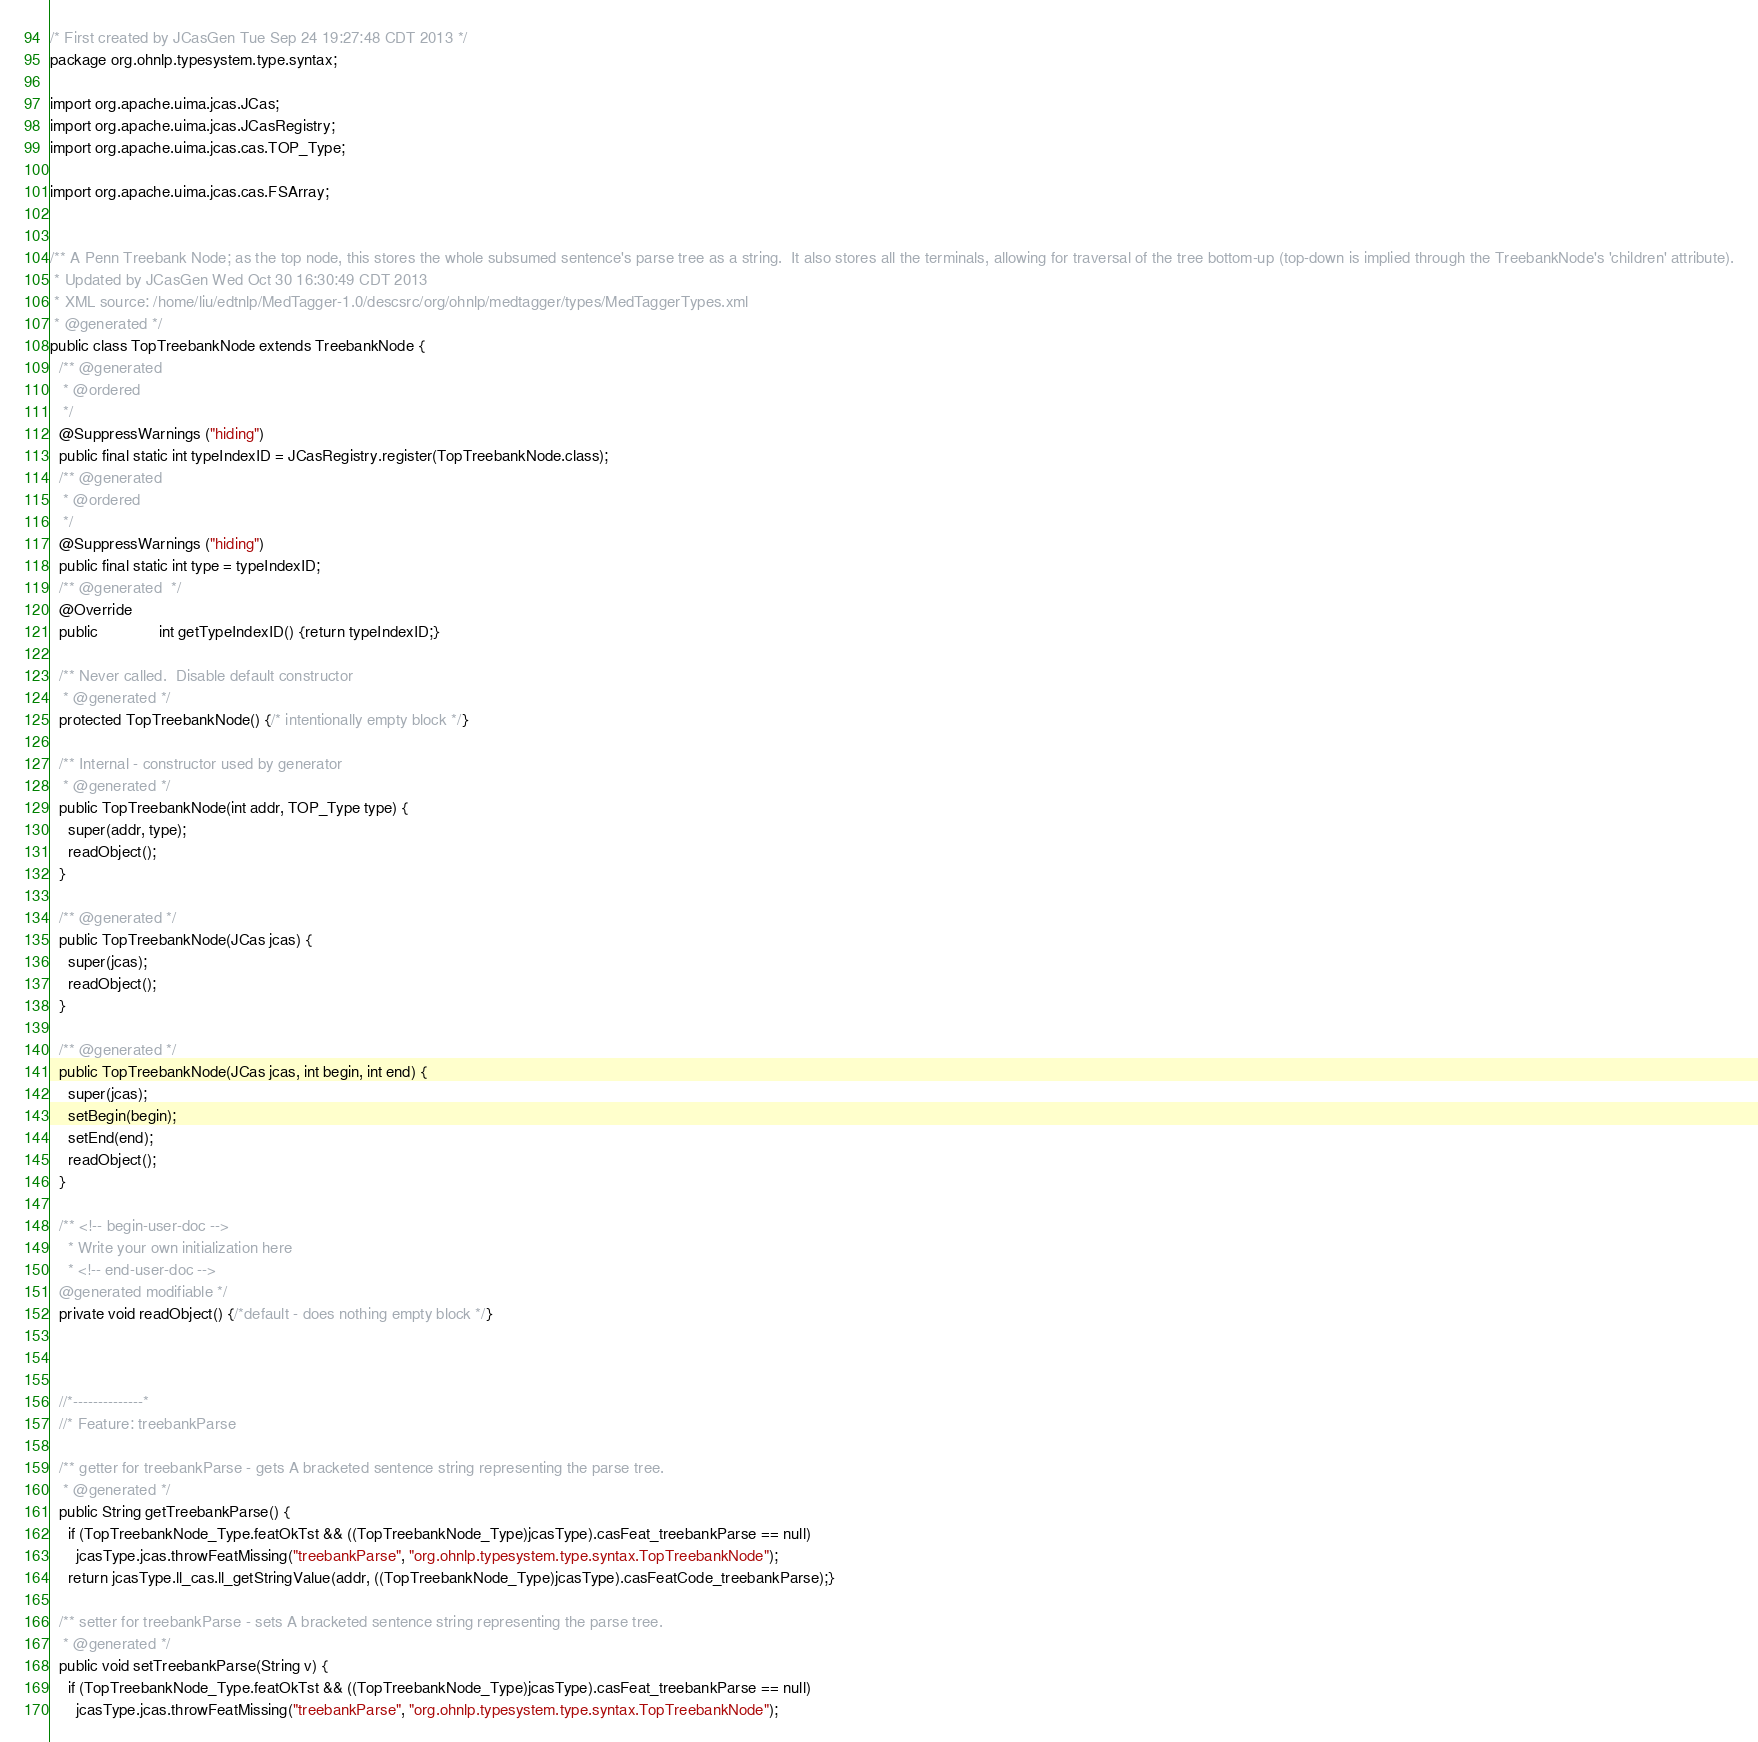Convert code to text. <code><loc_0><loc_0><loc_500><loc_500><_Java_>

/* First created by JCasGen Tue Sep 24 19:27:48 CDT 2013 */
package org.ohnlp.typesystem.type.syntax;

import org.apache.uima.jcas.JCas; 
import org.apache.uima.jcas.JCasRegistry;
import org.apache.uima.jcas.cas.TOP_Type;

import org.apache.uima.jcas.cas.FSArray;


/** A Penn Treebank Node; as the top node, this stores the whole subsumed sentence's parse tree as a string.  It also stores all the terminals, allowing for traversal of the tree bottom-up (top-down is implied through the TreebankNode's 'children' attribute).
 * Updated by JCasGen Wed Oct 30 16:30:49 CDT 2013
 * XML source: /home/liu/edtnlp/MedTagger-1.0/descsrc/org/ohnlp/medtagger/types/MedTaggerTypes.xml
 * @generated */
public class TopTreebankNode extends TreebankNode {
  /** @generated
   * @ordered 
   */
  @SuppressWarnings ("hiding")
  public final static int typeIndexID = JCasRegistry.register(TopTreebankNode.class);
  /** @generated
   * @ordered 
   */
  @SuppressWarnings ("hiding")
  public final static int type = typeIndexID;
  /** @generated  */
  @Override
  public              int getTypeIndexID() {return typeIndexID;}
 
  /** Never called.  Disable default constructor
   * @generated */
  protected TopTreebankNode() {/* intentionally empty block */}
    
  /** Internal - constructor used by generator 
   * @generated */
  public TopTreebankNode(int addr, TOP_Type type) {
    super(addr, type);
    readObject();
  }
  
  /** @generated */
  public TopTreebankNode(JCas jcas) {
    super(jcas);
    readObject();   
  } 

  /** @generated */  
  public TopTreebankNode(JCas jcas, int begin, int end) {
    super(jcas);
    setBegin(begin);
    setEnd(end);
    readObject();
  }   

  /** <!-- begin-user-doc -->
    * Write your own initialization here
    * <!-- end-user-doc -->
  @generated modifiable */
  private void readObject() {/*default - does nothing empty block */}
     
 
    
  //*--------------*
  //* Feature: treebankParse

  /** getter for treebankParse - gets A bracketed sentence string representing the parse tree.
   * @generated */
  public String getTreebankParse() {
    if (TopTreebankNode_Type.featOkTst && ((TopTreebankNode_Type)jcasType).casFeat_treebankParse == null)
      jcasType.jcas.throwFeatMissing("treebankParse", "org.ohnlp.typesystem.type.syntax.TopTreebankNode");
    return jcasType.ll_cas.ll_getStringValue(addr, ((TopTreebankNode_Type)jcasType).casFeatCode_treebankParse);}
    
  /** setter for treebankParse - sets A bracketed sentence string representing the parse tree. 
   * @generated */
  public void setTreebankParse(String v) {
    if (TopTreebankNode_Type.featOkTst && ((TopTreebankNode_Type)jcasType).casFeat_treebankParse == null)
      jcasType.jcas.throwFeatMissing("treebankParse", "org.ohnlp.typesystem.type.syntax.TopTreebankNode");</code> 